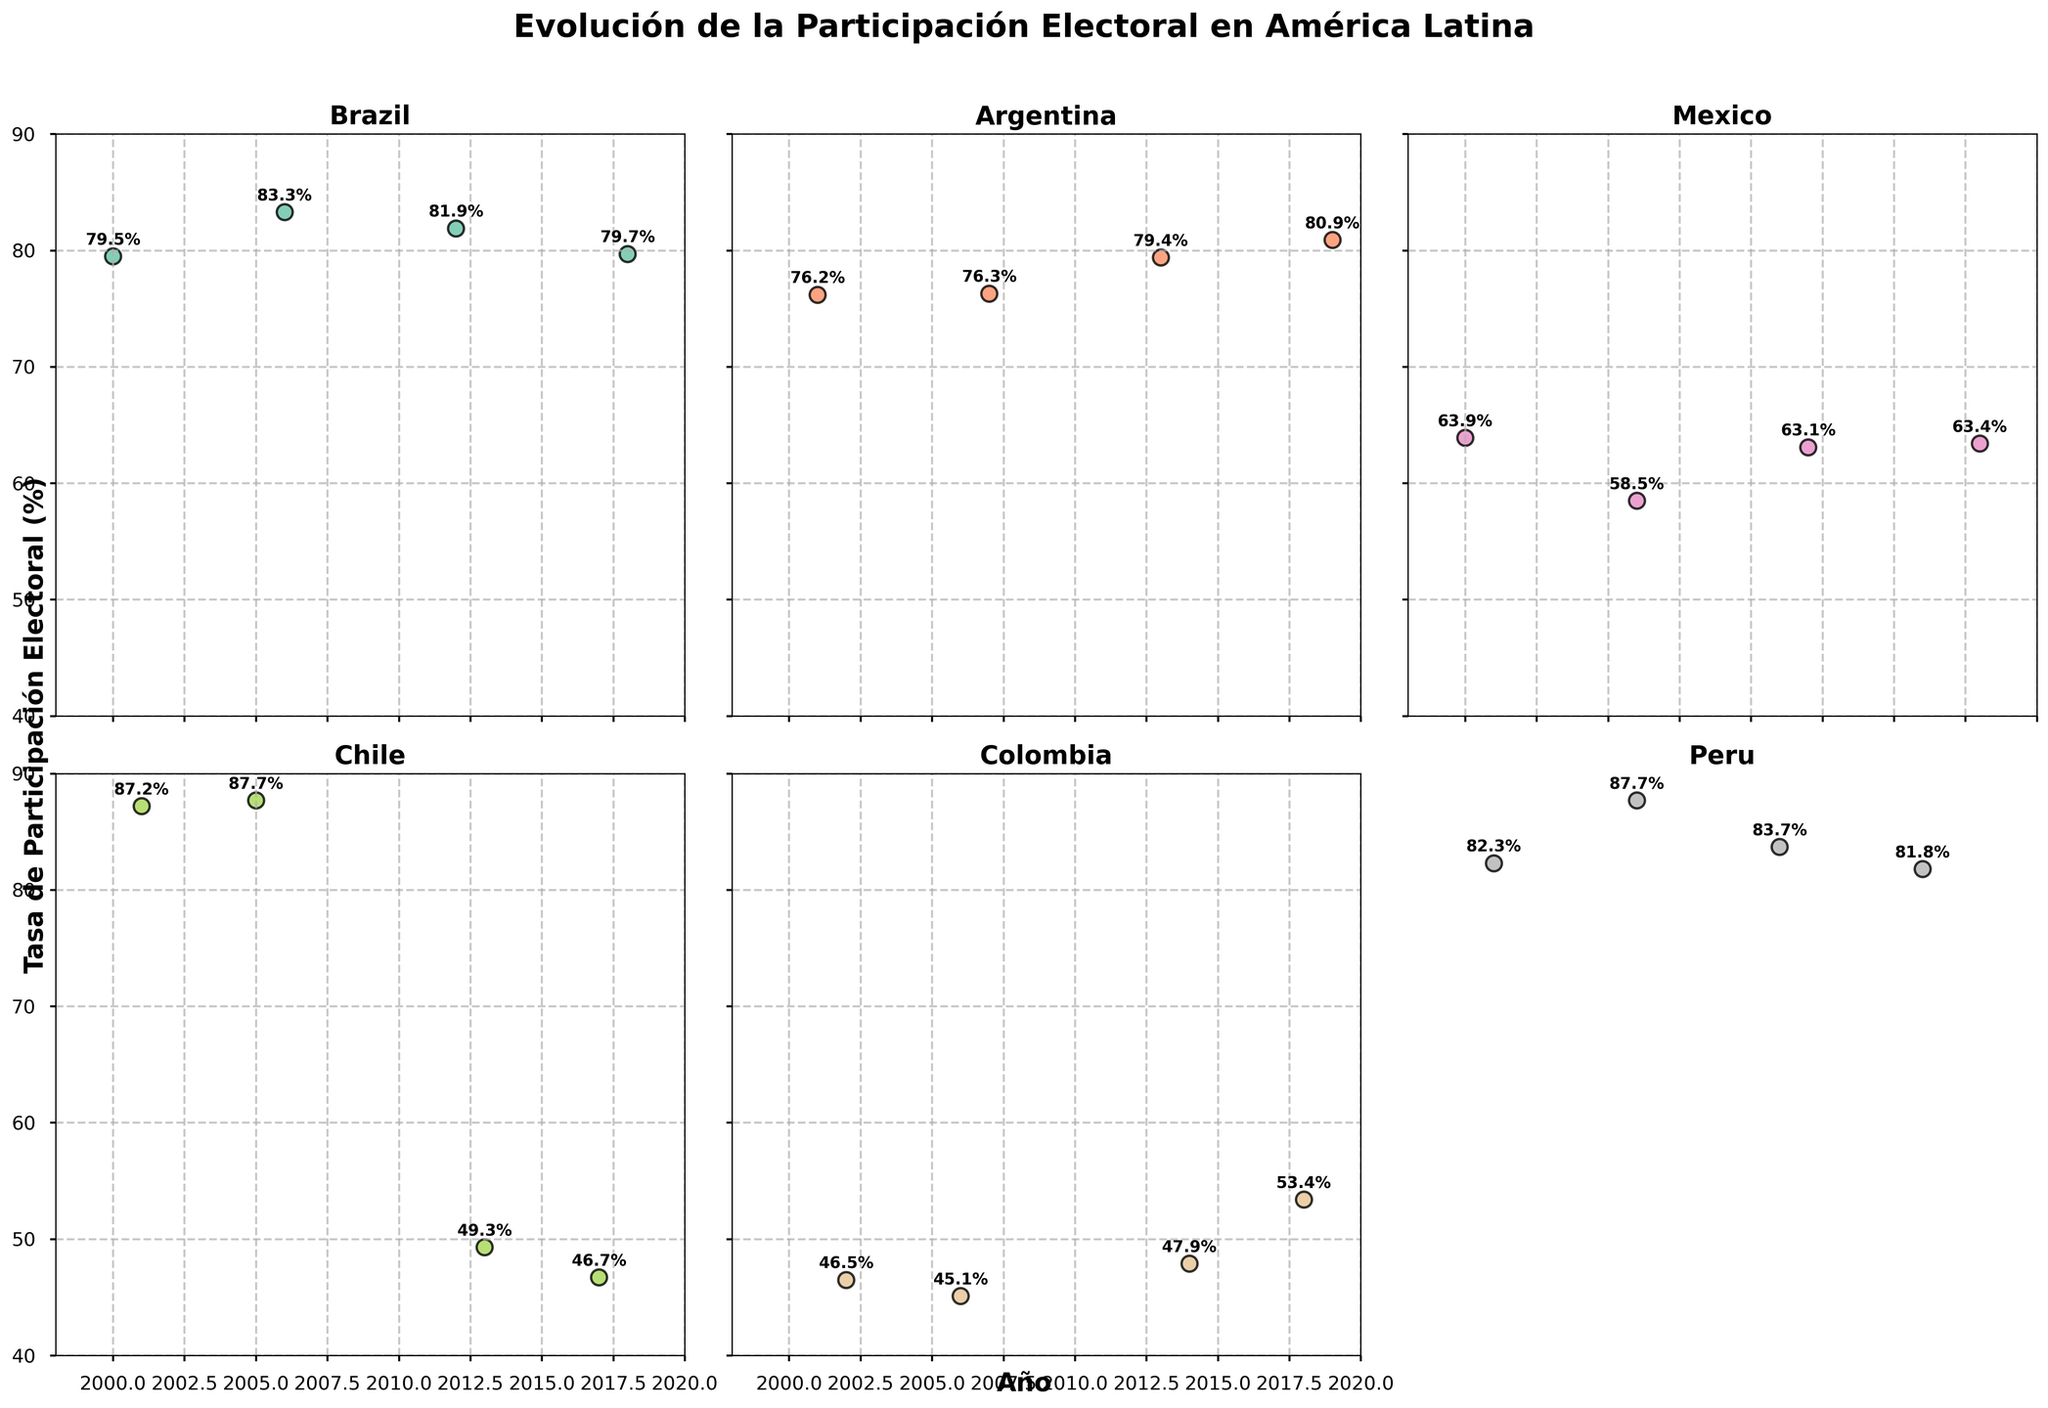Which country has the highest peak in electoral participation? By observing the maximum values in the scatter plots of each country, it is noticeable that Chile's participation rate reaches 87.7%, which is the highest among all countries.
Answer: Chile Between which years did Chile experience a significant drop in electoral participation? Comparing the values for Chile over different years, there is a significant drop between 2005 (87.7%) and 2013 (49.3%).
Answer: 2005 to 2013 Which country has the lowest recorded participation rate, and in which year? By looking at the lowest points in the scatter plots, Colombia in 2006 has the lowest participation rate at 45.1%.
Answer: Colombia, 2006 What is the general trend in electoral participation in Argentina from 2001 to 2019? Observing the scatter points for Argentina, the electoral participation rate is generally increasing from 76.2% in 2001 to 80.9% in 2019.
Answer: Increasing Compare the participation rate trend of Brazil and Peru. Which country shows a more stable trend? Brazil's participation fluctuates slightly between 79.5% and 83.3%, while Peru's rates are more variable, though relatively stable in high ranges. Brazil shows less fluctuation.
Answer: Brazil How does Mexico's electoral participation rate change from 2000 to 2018? Mexico’s scatter points indicate a slight decline from 63.9% in 2000 to 58.5% in 2006, then a gradual increase to 63.4% in 2018.
Answer: Decline then increase What countries experienced an electoral participation below 50% in any recorded year? From the scatter plots, Chile (2013: 49.3%, 2017: 46.7%) and Colombia (2002: 46.5%, 2006: 45.1%) had rates below 50%.
Answer: Chile, Colombia In which year did Colombia see the largest increase in electoral participation rate? By examining the rate changes, Colombia saw the largest increase from 2014 (47.9%) to 2018 (53.4%), an increase of 5.5%.
Answer: 2018 